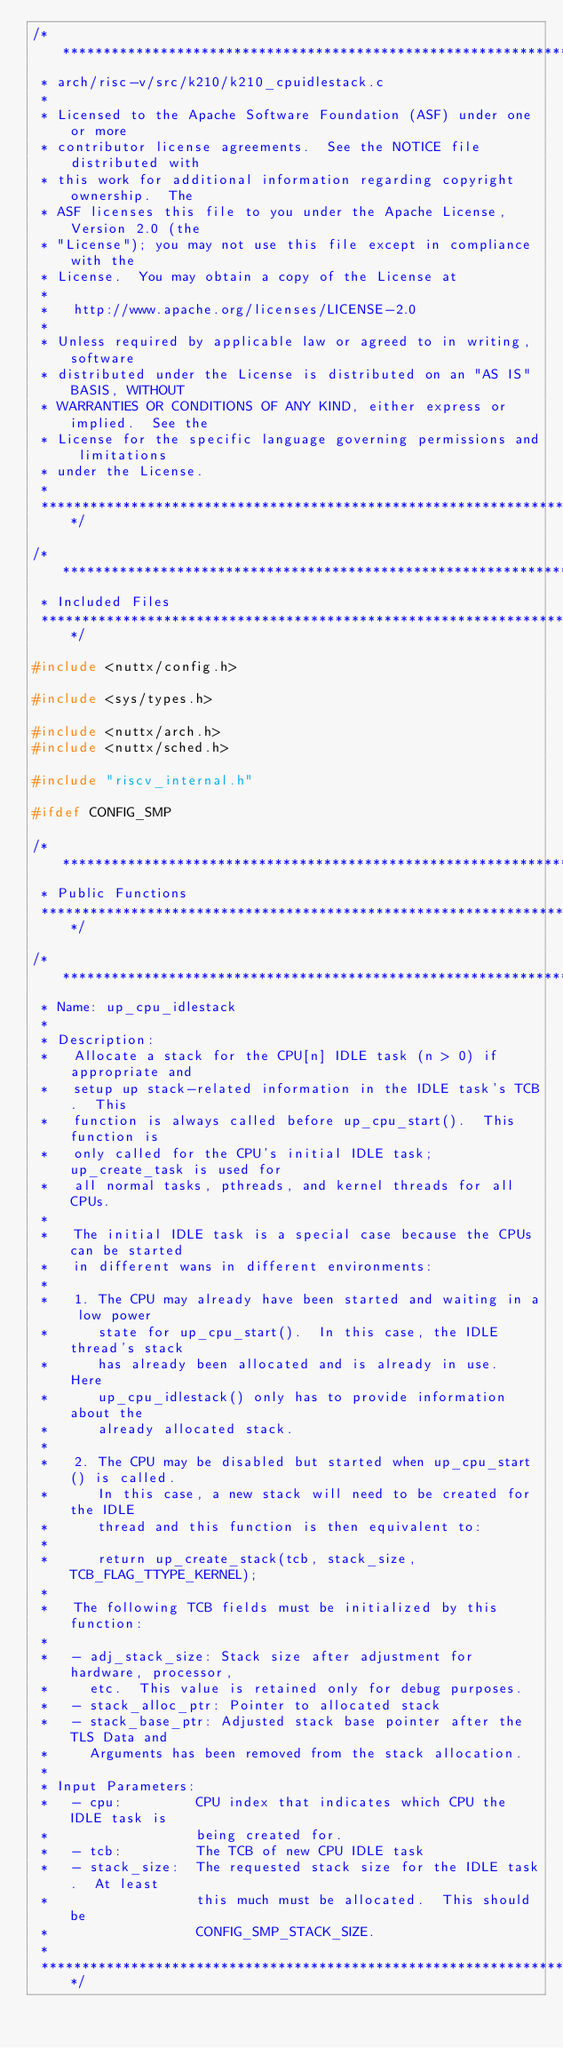Convert code to text. <code><loc_0><loc_0><loc_500><loc_500><_C_>/****************************************************************************
 * arch/risc-v/src/k210/k210_cpuidlestack.c
 *
 * Licensed to the Apache Software Foundation (ASF) under one or more
 * contributor license agreements.  See the NOTICE file distributed with
 * this work for additional information regarding copyright ownership.  The
 * ASF licenses this file to you under the Apache License, Version 2.0 (the
 * "License"); you may not use this file except in compliance with the
 * License.  You may obtain a copy of the License at
 *
 *   http://www.apache.org/licenses/LICENSE-2.0
 *
 * Unless required by applicable law or agreed to in writing, software
 * distributed under the License is distributed on an "AS IS" BASIS, WITHOUT
 * WARRANTIES OR CONDITIONS OF ANY KIND, either express or implied.  See the
 * License for the specific language governing permissions and limitations
 * under the License.
 *
 ****************************************************************************/

/****************************************************************************
 * Included Files
 ****************************************************************************/

#include <nuttx/config.h>

#include <sys/types.h>

#include <nuttx/arch.h>
#include <nuttx/sched.h>

#include "riscv_internal.h"

#ifdef CONFIG_SMP

/****************************************************************************
 * Public Functions
 ****************************************************************************/

/****************************************************************************
 * Name: up_cpu_idlestack
 *
 * Description:
 *   Allocate a stack for the CPU[n] IDLE task (n > 0) if appropriate and
 *   setup up stack-related information in the IDLE task's TCB.  This
 *   function is always called before up_cpu_start().  This function is
 *   only called for the CPU's initial IDLE task; up_create_task is used for
 *   all normal tasks, pthreads, and kernel threads for all CPUs.
 *
 *   The initial IDLE task is a special case because the CPUs can be started
 *   in different wans in different environments:
 *
 *   1. The CPU may already have been started and waiting in a low power
 *      state for up_cpu_start().  In this case, the IDLE thread's stack
 *      has already been allocated and is already in use.  Here
 *      up_cpu_idlestack() only has to provide information about the
 *      already allocated stack.
 *
 *   2. The CPU may be disabled but started when up_cpu_start() is called.
 *      In this case, a new stack will need to be created for the IDLE
 *      thread and this function is then equivalent to:
 *
 *      return up_create_stack(tcb, stack_size, TCB_FLAG_TTYPE_KERNEL);
 *
 *   The following TCB fields must be initialized by this function:
 *
 *   - adj_stack_size: Stack size after adjustment for hardware, processor,
 *     etc.  This value is retained only for debug purposes.
 *   - stack_alloc_ptr: Pointer to allocated stack
 *   - stack_base_ptr: Adjusted stack base pointer after the TLS Data and
 *     Arguments has been removed from the stack allocation.
 *
 * Input Parameters:
 *   - cpu:         CPU index that indicates which CPU the IDLE task is
 *                  being created for.
 *   - tcb:         The TCB of new CPU IDLE task
 *   - stack_size:  The requested stack size for the IDLE task.  At least
 *                  this much must be allocated.  This should be
 *                  CONFIG_SMP_STACK_SIZE.
 *
 ****************************************************************************/
</code> 